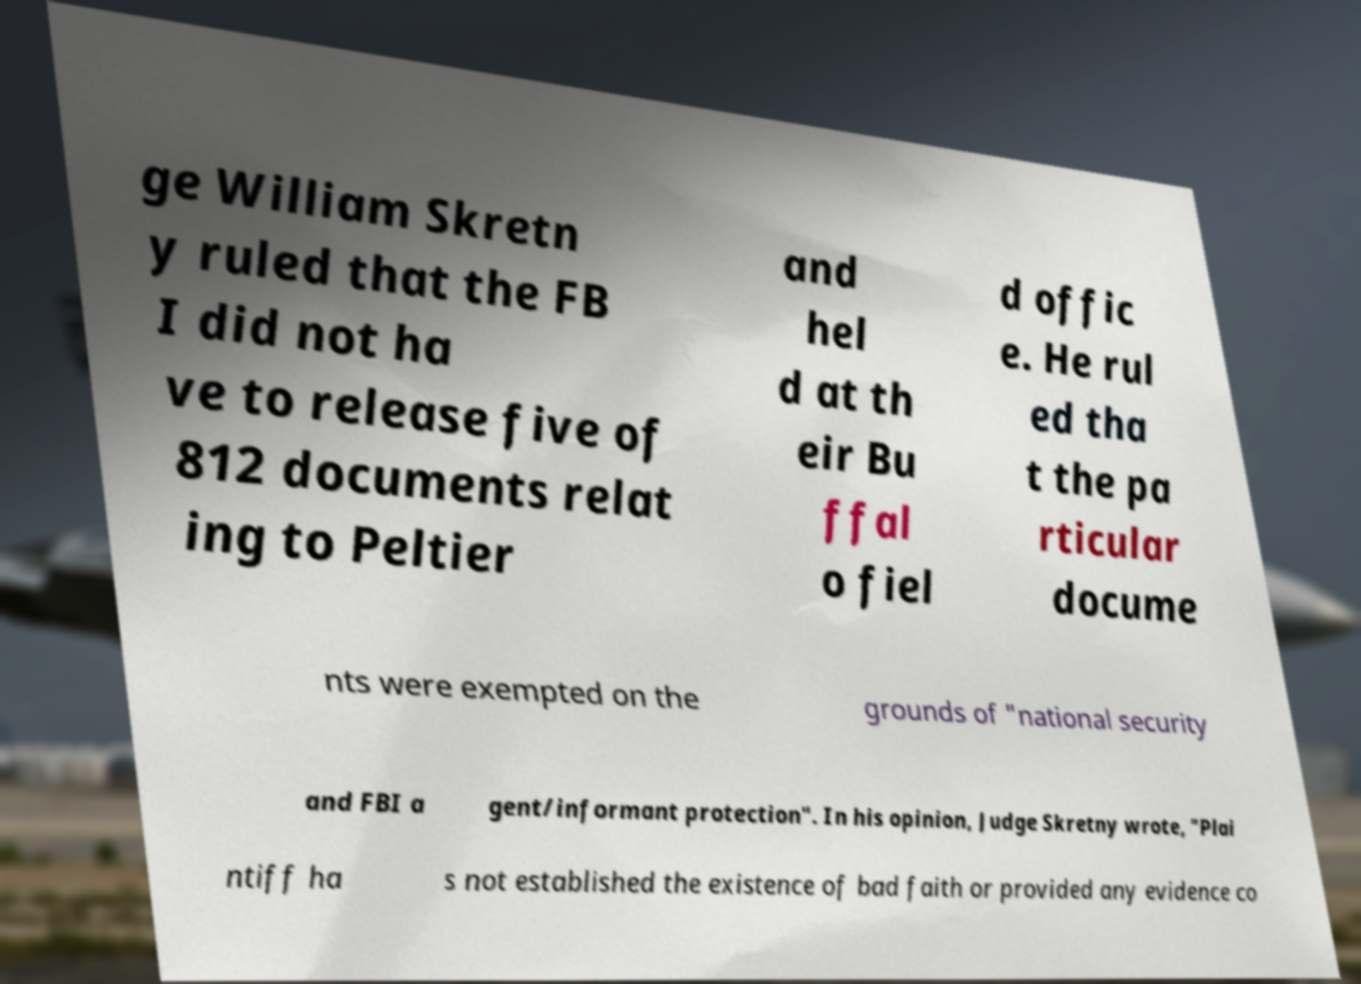I need the written content from this picture converted into text. Can you do that? ge William Skretn y ruled that the FB I did not ha ve to release five of 812 documents relat ing to Peltier and hel d at th eir Bu ffal o fiel d offic e. He rul ed tha t the pa rticular docume nts were exempted on the grounds of "national security and FBI a gent/informant protection". In his opinion, Judge Skretny wrote, "Plai ntiff ha s not established the existence of bad faith or provided any evidence co 